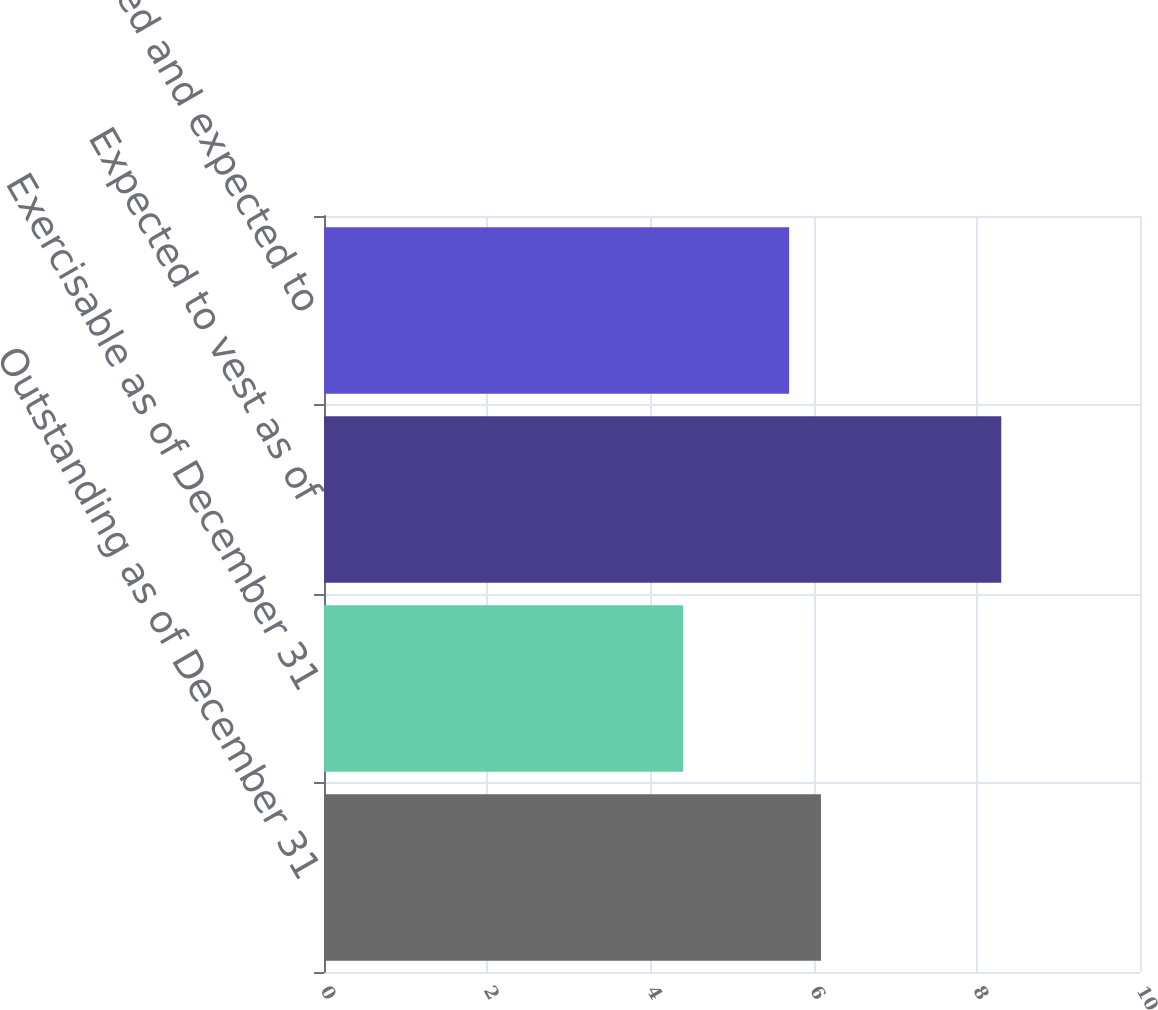Convert chart to OTSL. <chart><loc_0><loc_0><loc_500><loc_500><bar_chart><fcel>Outstanding as of December 31<fcel>Exercisable as of December 31<fcel>Expected to vest as of<fcel>Total vested and expected to<nl><fcel>6.09<fcel>4.4<fcel>8.3<fcel>5.7<nl></chart> 